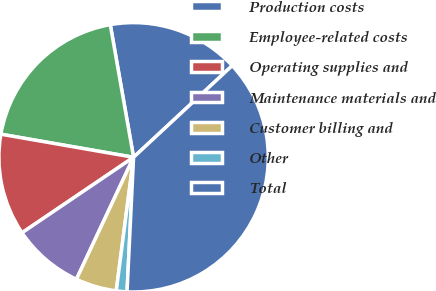Convert chart. <chart><loc_0><loc_0><loc_500><loc_500><pie_chart><fcel>Production costs<fcel>Employee-related costs<fcel>Operating supplies and<fcel>Maintenance materials and<fcel>Customer billing and<fcel>Other<fcel>Total<nl><fcel>15.85%<fcel>19.49%<fcel>12.21%<fcel>8.56%<fcel>4.92%<fcel>1.28%<fcel>37.69%<nl></chart> 